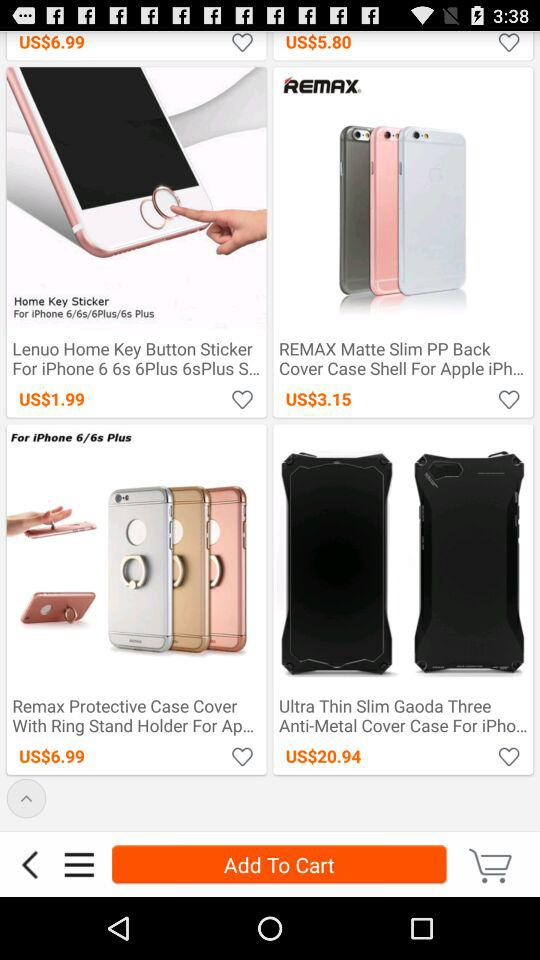How many items have a price of less than $5?
Answer the question using a single word or phrase. 2 